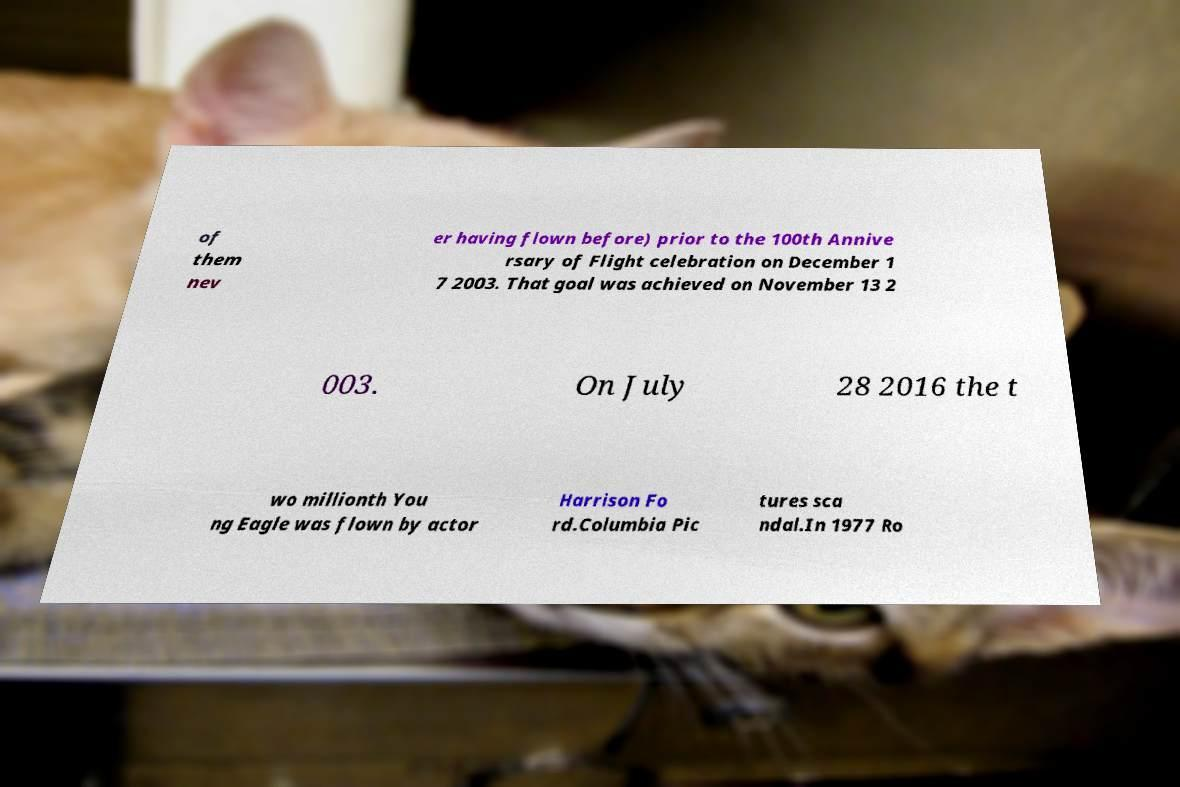Could you assist in decoding the text presented in this image and type it out clearly? of them nev er having flown before) prior to the 100th Annive rsary of Flight celebration on December 1 7 2003. That goal was achieved on November 13 2 003. On July 28 2016 the t wo millionth You ng Eagle was flown by actor Harrison Fo rd.Columbia Pic tures sca ndal.In 1977 Ro 